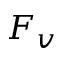<formula> <loc_0><loc_0><loc_500><loc_500>F _ { v }</formula> 